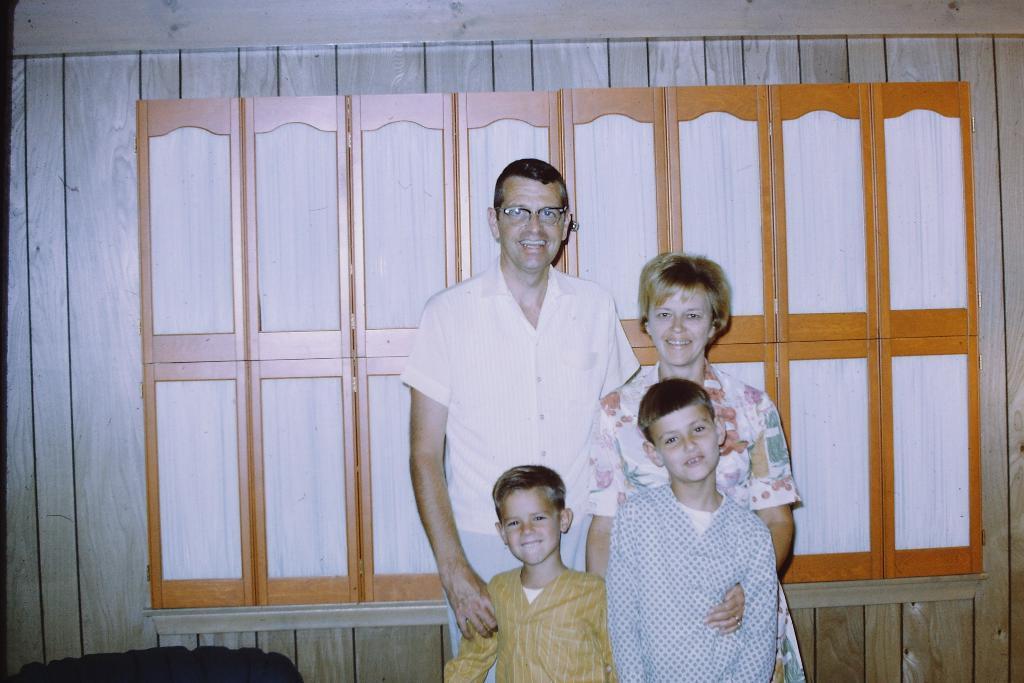Could you give a brief overview of what you see in this image? In this image, in the background there are four people looking at someone. 